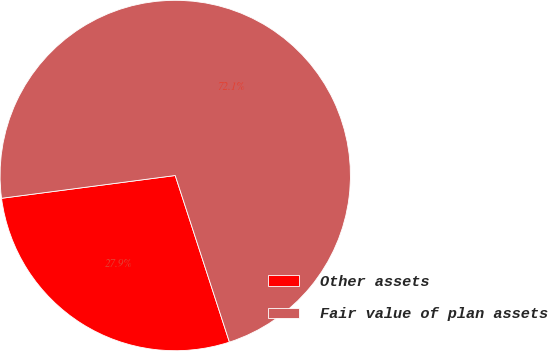Convert chart to OTSL. <chart><loc_0><loc_0><loc_500><loc_500><pie_chart><fcel>Other assets<fcel>Fair value of plan assets<nl><fcel>27.93%<fcel>72.07%<nl></chart> 